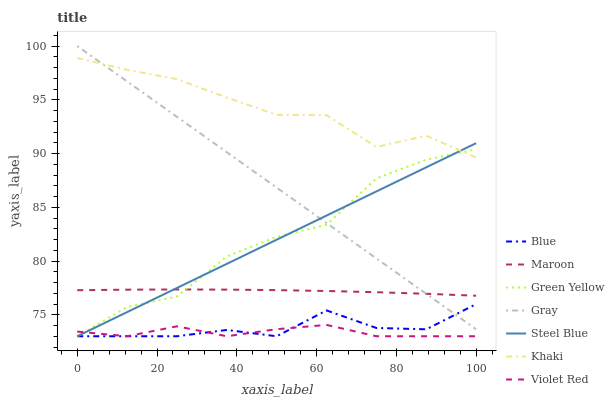Does Violet Red have the minimum area under the curve?
Answer yes or no. Yes. Does Khaki have the maximum area under the curve?
Answer yes or no. Yes. Does Gray have the minimum area under the curve?
Answer yes or no. No. Does Gray have the maximum area under the curve?
Answer yes or no. No. Is Steel Blue the smoothest?
Answer yes or no. Yes. Is Green Yellow the roughest?
Answer yes or no. Yes. Is Gray the smoothest?
Answer yes or no. No. Is Gray the roughest?
Answer yes or no. No. Does Blue have the lowest value?
Answer yes or no. Yes. Does Gray have the lowest value?
Answer yes or no. No. Does Gray have the highest value?
Answer yes or no. Yes. Does Violet Red have the highest value?
Answer yes or no. No. Is Violet Red less than Gray?
Answer yes or no. Yes. Is Maroon greater than Violet Red?
Answer yes or no. Yes. Does Khaki intersect Steel Blue?
Answer yes or no. Yes. Is Khaki less than Steel Blue?
Answer yes or no. No. Is Khaki greater than Steel Blue?
Answer yes or no. No. Does Violet Red intersect Gray?
Answer yes or no. No. 